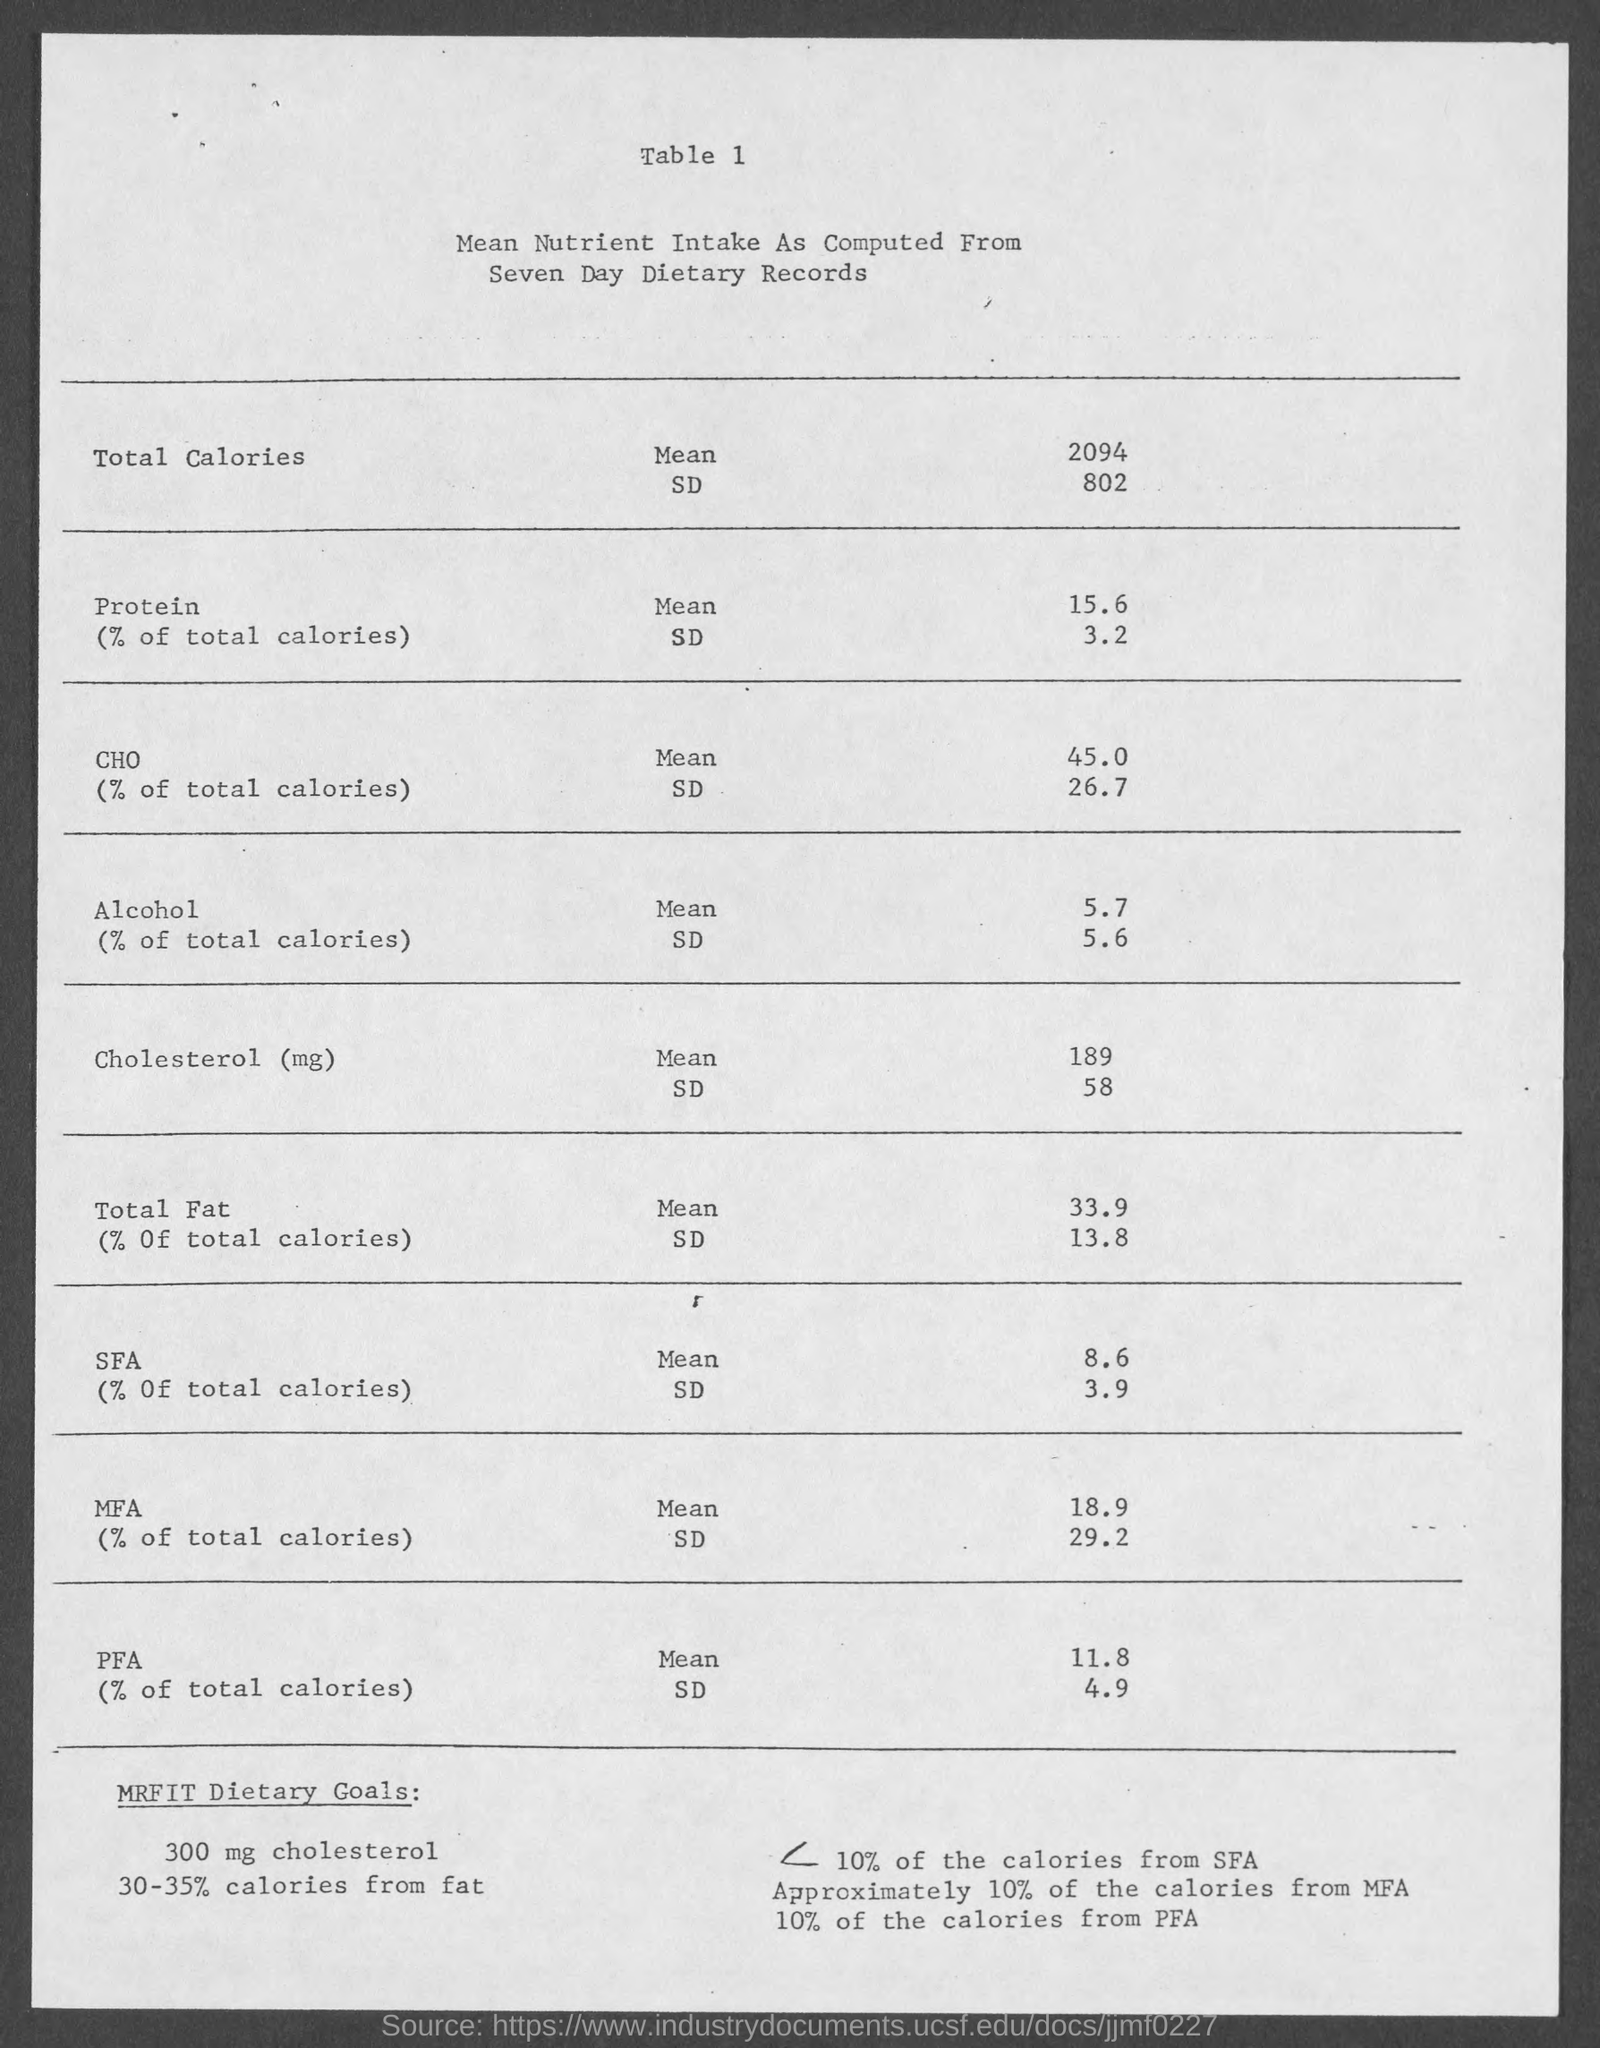What is the amount of mean intake of total calories ?
Your answer should be compact. 2094. What is the mean intake of % of total calories in protein ?
Offer a very short reply. 15.6. What is the mean intake of % of total calories of cho ?
Give a very brief answer. 45.0. What is the sd value of mfa as mentioned in the given table ?
Your answer should be compact. 29.2. What is the sd value of cho as mentioned in the given table ?
Your answer should be very brief. 26.7. What is the sd value of protein mentioned in the given table ?
Provide a succinct answer. 3.2. What is the mean intake value of total fat as mentioned in the given table ?
Keep it short and to the point. 33.9. What is the sd value of alcohol as mentioned in the given table ?
Provide a short and direct response. 5.6. What is the mean intake value of alcohol mentioned in the given table ?
Offer a terse response. 5.7. 